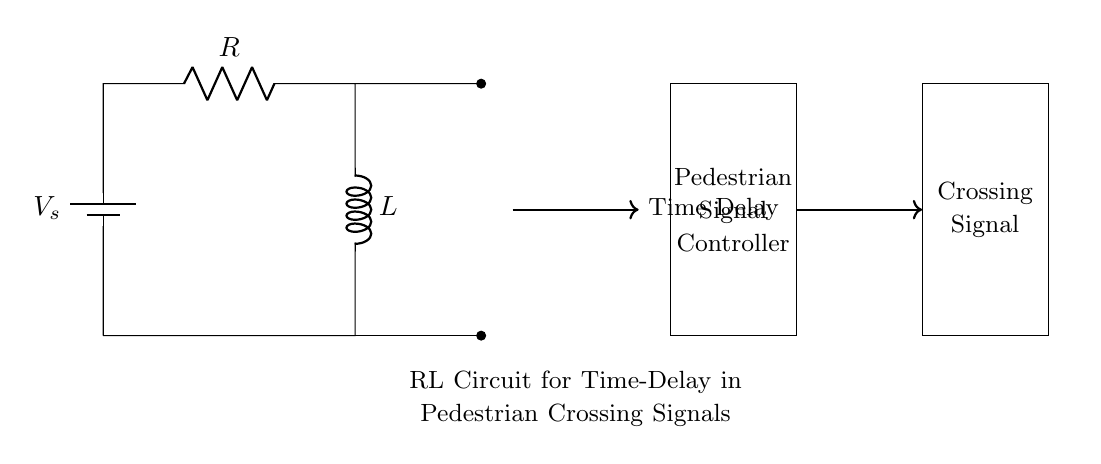What components are present in this circuit? The circuit includes a voltage source, a resistor, and an inductor. These components are essential for forming the RL circuit.
Answer: Voltage source, resistor, inductor What does the inductor in the circuit do? The inductor stores energy in a magnetic field when current flows through it. The buildup of this current takes time, contributing to the delay mechanism in the circuit.
Answer: Stores energy What is the purpose of the resistor in this circuit? The resistor limits the current flowing through the circuit. In conjunction with the inductor, it affects the time constant of the circuit, influencing the delay for the pedestrian signal.
Answer: Limits current What is the function of this RL circuit in pedestrian signals? This RL circuit creates a time delay that allows for safe crossing by controlling how quickly the pedestrian signal activates, ensuring it doesn't turn on immediately when the button is pressed.
Answer: Time delay How does the time delay relate to the properties of the inductor and resistor? The time delay is determined by the time constant, which is the product of resistance and inductance (tau = R * L). A larger resistance or inductance will increase the time delay, affecting how quickly the signal changes.
Answer: R times L 